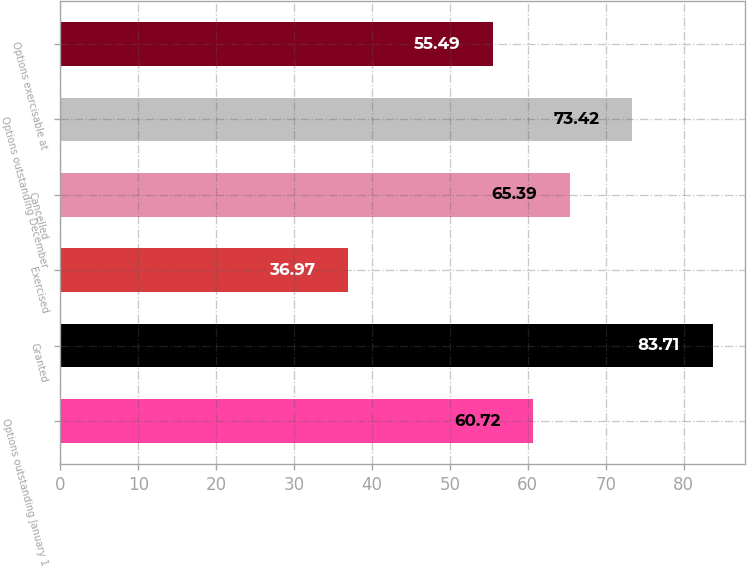Convert chart to OTSL. <chart><loc_0><loc_0><loc_500><loc_500><bar_chart><fcel>Options outstanding January 1<fcel>Granted<fcel>Exercised<fcel>Cancelled<fcel>Options outstanding December<fcel>Options exercisable at<nl><fcel>60.72<fcel>83.71<fcel>36.97<fcel>65.39<fcel>73.42<fcel>55.49<nl></chart> 